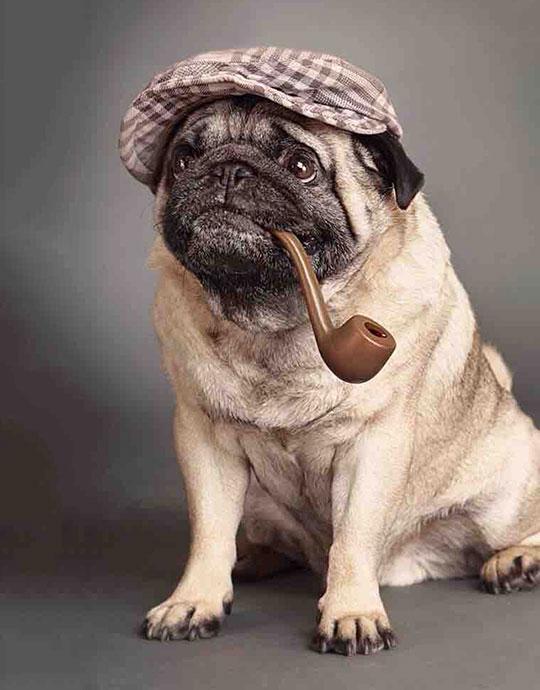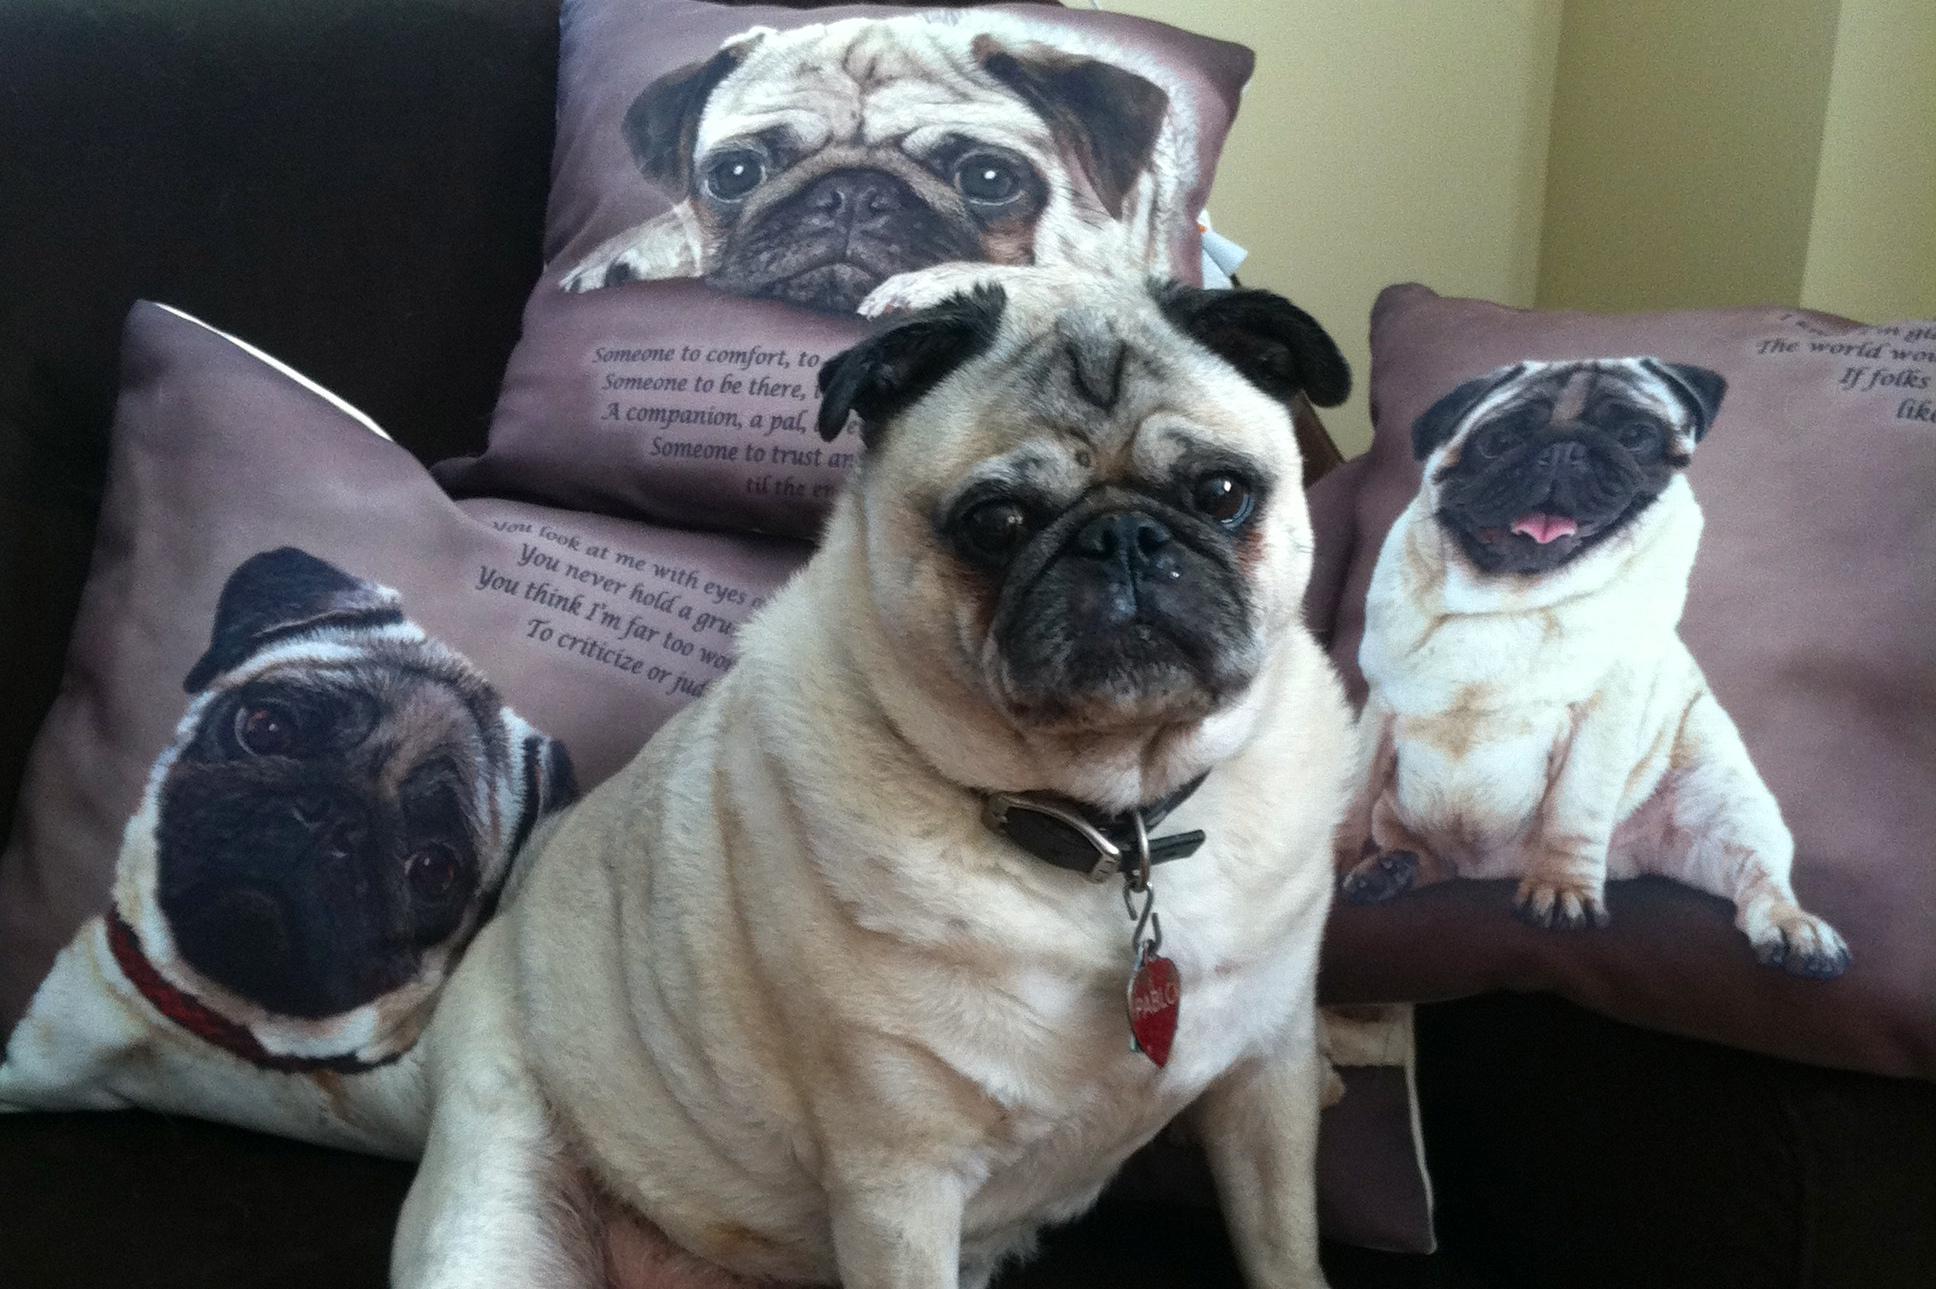The first image is the image on the left, the second image is the image on the right. Considering the images on both sides, is "A human is playing with puppies on the floor" valid? Answer yes or no. No. The first image is the image on the left, the second image is the image on the right. For the images shown, is this caption "A man in a blue and white striped shirt is nuzzling puppies." true? Answer yes or no. No. 